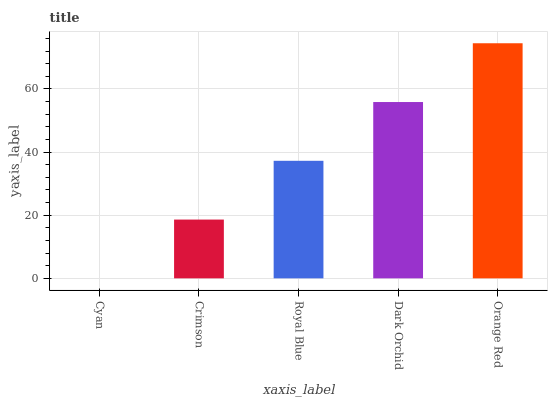Is Cyan the minimum?
Answer yes or no. Yes. Is Orange Red the maximum?
Answer yes or no. Yes. Is Crimson the minimum?
Answer yes or no. No. Is Crimson the maximum?
Answer yes or no. No. Is Crimson greater than Cyan?
Answer yes or no. Yes. Is Cyan less than Crimson?
Answer yes or no. Yes. Is Cyan greater than Crimson?
Answer yes or no. No. Is Crimson less than Cyan?
Answer yes or no. No. Is Royal Blue the high median?
Answer yes or no. Yes. Is Royal Blue the low median?
Answer yes or no. Yes. Is Orange Red the high median?
Answer yes or no. No. Is Dark Orchid the low median?
Answer yes or no. No. 